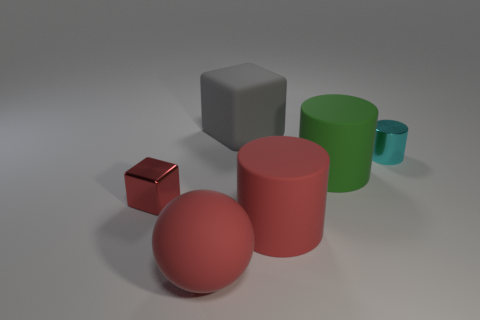Can you describe the colors of the objects? Sure, the image showcases objects with various colors: the large sphere is red, the small sphere is also red but with a slightly different shade, the cylinder is pink, the small block is reflective and seems to resemble copper, and the large block has a neutral grey color. The mug-like object is green. 